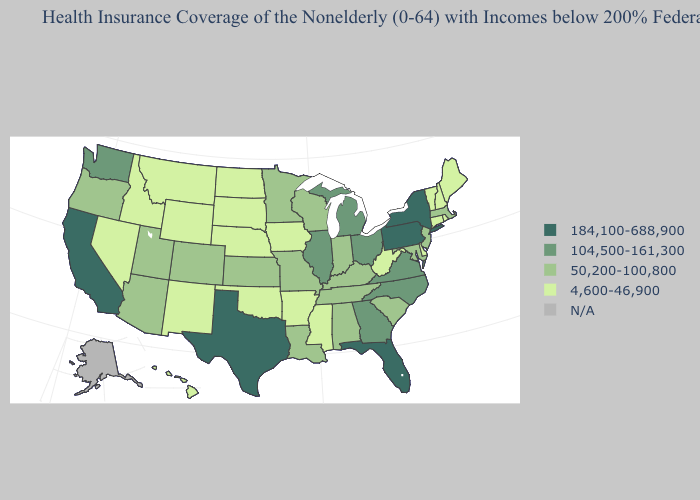Does Pennsylvania have the highest value in the Northeast?
Keep it brief. Yes. Name the states that have a value in the range 184,100-688,900?
Write a very short answer. California, Florida, New York, Pennsylvania, Texas. Among the states that border Colorado , which have the highest value?
Give a very brief answer. Arizona, Kansas, Utah. Name the states that have a value in the range 184,100-688,900?
Concise answer only. California, Florida, New York, Pennsylvania, Texas. Does the map have missing data?
Write a very short answer. Yes. What is the lowest value in states that border Wyoming?
Give a very brief answer. 4,600-46,900. Does Nevada have the highest value in the West?
Concise answer only. No. How many symbols are there in the legend?
Short answer required. 5. What is the highest value in the USA?
Keep it brief. 184,100-688,900. What is the lowest value in the USA?
Be succinct. 4,600-46,900. Which states have the lowest value in the South?
Give a very brief answer. Arkansas, Delaware, Mississippi, Oklahoma, West Virginia. Among the states that border Missouri , which have the highest value?
Be succinct. Illinois. What is the value of South Carolina?
Quick response, please. 50,200-100,800. Which states hav the highest value in the West?
Write a very short answer. California. Name the states that have a value in the range 184,100-688,900?
Answer briefly. California, Florida, New York, Pennsylvania, Texas. 